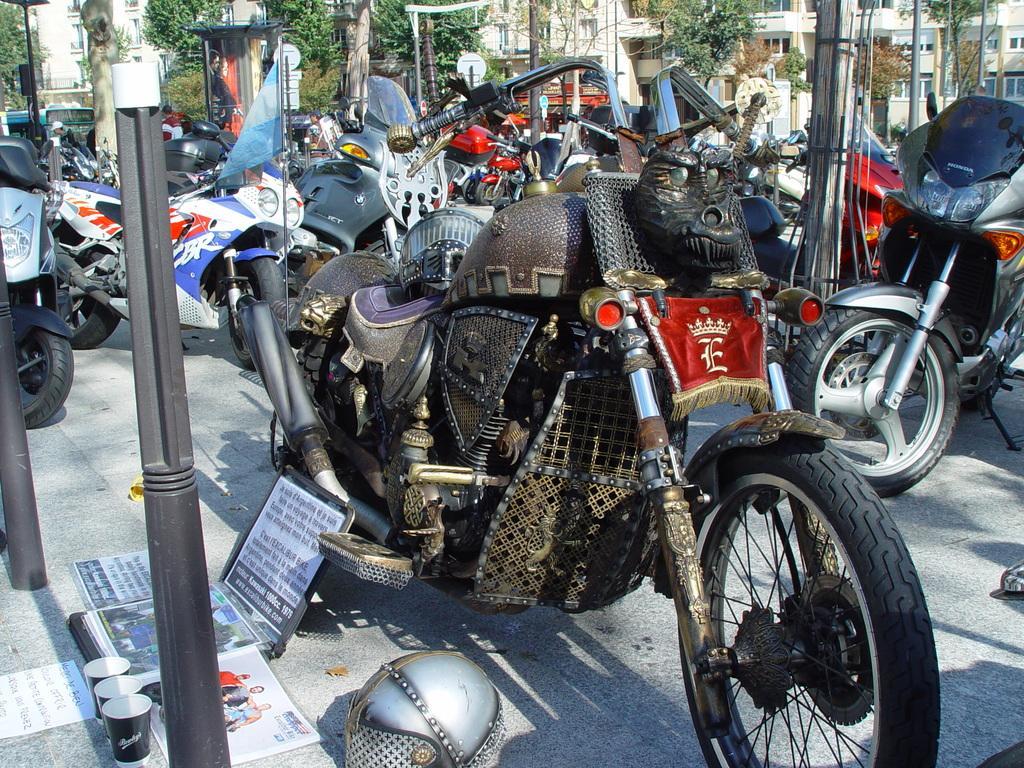How would you summarize this image in a sentence or two? In this image few vehicles are on the floor. Left bottom of the image there is a helmet, few posters, glasses and poles are on the floor. Left side there is a flag. Background there are trees and buildings. 